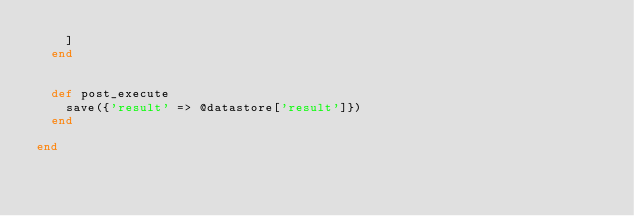<code> <loc_0><loc_0><loc_500><loc_500><_Ruby_>    ]
  end


  def post_execute
    save({'result' => @datastore['result']})
  end

end
</code> 